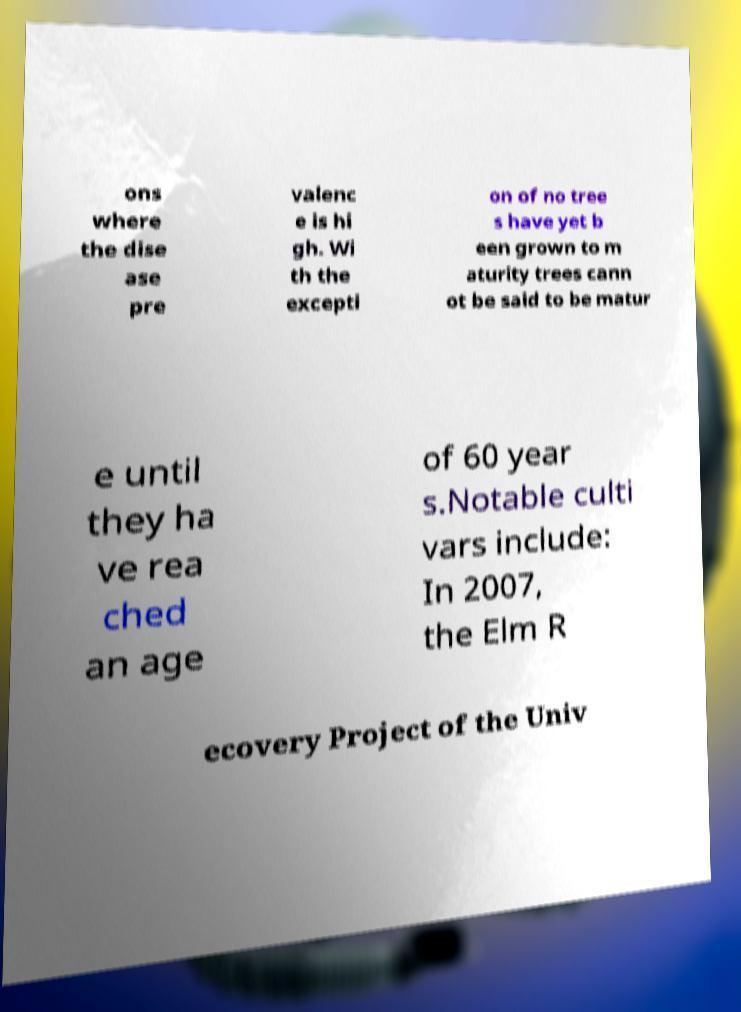I need the written content from this picture converted into text. Can you do that? ons where the dise ase pre valenc e is hi gh. Wi th the excepti on of no tree s have yet b een grown to m aturity trees cann ot be said to be matur e until they ha ve rea ched an age of 60 year s.Notable culti vars include: In 2007, the Elm R ecovery Project of the Univ 